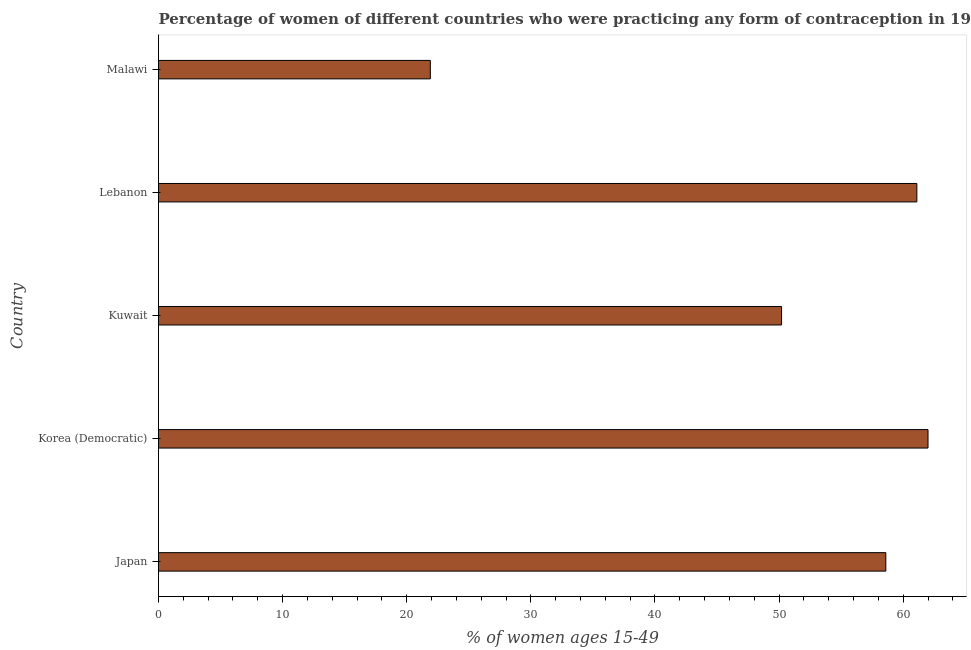What is the title of the graph?
Ensure brevity in your answer.  Percentage of women of different countries who were practicing any form of contraception in 1996. What is the label or title of the X-axis?
Your response must be concise. % of women ages 15-49. What is the contraceptive prevalence in Korea (Democratic)?
Your answer should be very brief. 62. Across all countries, what is the maximum contraceptive prevalence?
Provide a short and direct response. 62. Across all countries, what is the minimum contraceptive prevalence?
Provide a succinct answer. 21.9. In which country was the contraceptive prevalence maximum?
Your answer should be very brief. Korea (Democratic). In which country was the contraceptive prevalence minimum?
Provide a succinct answer. Malawi. What is the sum of the contraceptive prevalence?
Offer a terse response. 253.8. What is the difference between the contraceptive prevalence in Lebanon and Malawi?
Your answer should be compact. 39.2. What is the average contraceptive prevalence per country?
Make the answer very short. 50.76. What is the median contraceptive prevalence?
Offer a very short reply. 58.6. What is the ratio of the contraceptive prevalence in Kuwait to that in Lebanon?
Make the answer very short. 0.82. Is the contraceptive prevalence in Korea (Democratic) less than that in Kuwait?
Give a very brief answer. No. Is the difference between the contraceptive prevalence in Japan and Kuwait greater than the difference between any two countries?
Provide a succinct answer. No. What is the difference between the highest and the second highest contraceptive prevalence?
Offer a terse response. 0.9. Is the sum of the contraceptive prevalence in Japan and Lebanon greater than the maximum contraceptive prevalence across all countries?
Ensure brevity in your answer.  Yes. What is the difference between the highest and the lowest contraceptive prevalence?
Your answer should be very brief. 40.1. In how many countries, is the contraceptive prevalence greater than the average contraceptive prevalence taken over all countries?
Provide a short and direct response. 3. How many countries are there in the graph?
Make the answer very short. 5. What is the difference between two consecutive major ticks on the X-axis?
Keep it short and to the point. 10. Are the values on the major ticks of X-axis written in scientific E-notation?
Provide a succinct answer. No. What is the % of women ages 15-49 of Japan?
Your response must be concise. 58.6. What is the % of women ages 15-49 of Korea (Democratic)?
Give a very brief answer. 62. What is the % of women ages 15-49 of Kuwait?
Give a very brief answer. 50.2. What is the % of women ages 15-49 in Lebanon?
Keep it short and to the point. 61.1. What is the % of women ages 15-49 of Malawi?
Ensure brevity in your answer.  21.9. What is the difference between the % of women ages 15-49 in Japan and Malawi?
Offer a very short reply. 36.7. What is the difference between the % of women ages 15-49 in Korea (Democratic) and Lebanon?
Provide a short and direct response. 0.9. What is the difference between the % of women ages 15-49 in Korea (Democratic) and Malawi?
Offer a very short reply. 40.1. What is the difference between the % of women ages 15-49 in Kuwait and Malawi?
Your response must be concise. 28.3. What is the difference between the % of women ages 15-49 in Lebanon and Malawi?
Offer a terse response. 39.2. What is the ratio of the % of women ages 15-49 in Japan to that in Korea (Democratic)?
Your answer should be very brief. 0.94. What is the ratio of the % of women ages 15-49 in Japan to that in Kuwait?
Give a very brief answer. 1.17. What is the ratio of the % of women ages 15-49 in Japan to that in Malawi?
Give a very brief answer. 2.68. What is the ratio of the % of women ages 15-49 in Korea (Democratic) to that in Kuwait?
Give a very brief answer. 1.24. What is the ratio of the % of women ages 15-49 in Korea (Democratic) to that in Lebanon?
Make the answer very short. 1.01. What is the ratio of the % of women ages 15-49 in Korea (Democratic) to that in Malawi?
Provide a succinct answer. 2.83. What is the ratio of the % of women ages 15-49 in Kuwait to that in Lebanon?
Give a very brief answer. 0.82. What is the ratio of the % of women ages 15-49 in Kuwait to that in Malawi?
Provide a short and direct response. 2.29. What is the ratio of the % of women ages 15-49 in Lebanon to that in Malawi?
Provide a succinct answer. 2.79. 